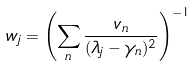<formula> <loc_0><loc_0><loc_500><loc_500>w _ { j } = \left ( \sum _ { n } \frac { v _ { n } } { ( \lambda _ { j } - \gamma _ { n } ) ^ { 2 } } \right ) ^ { - 1 }</formula> 